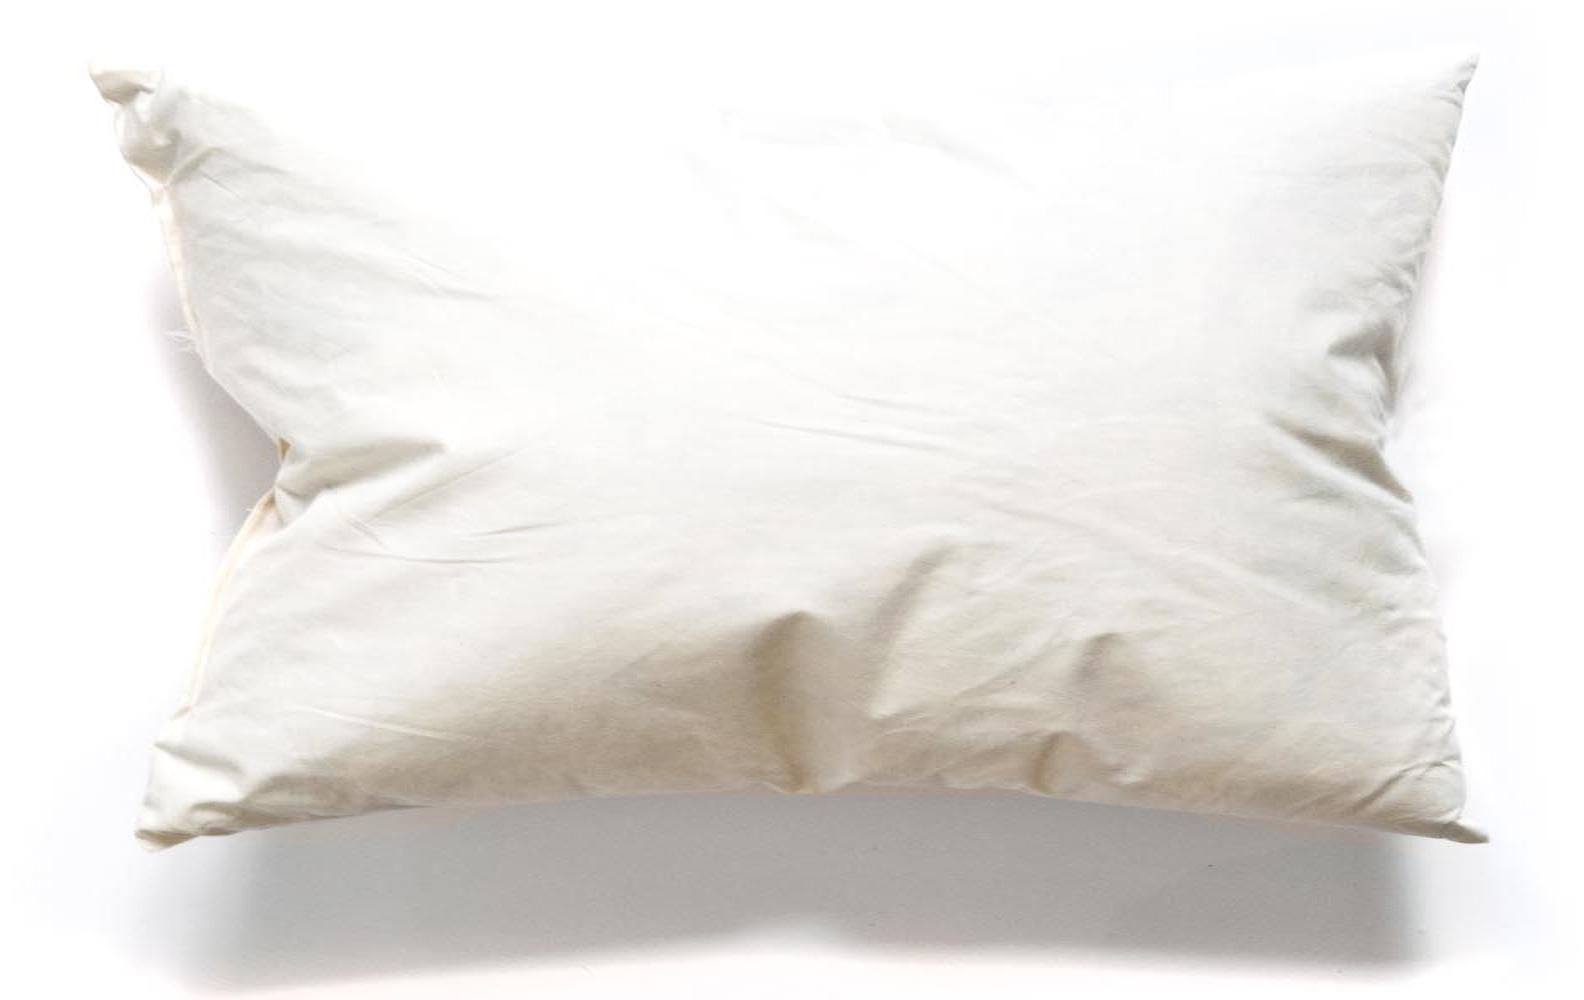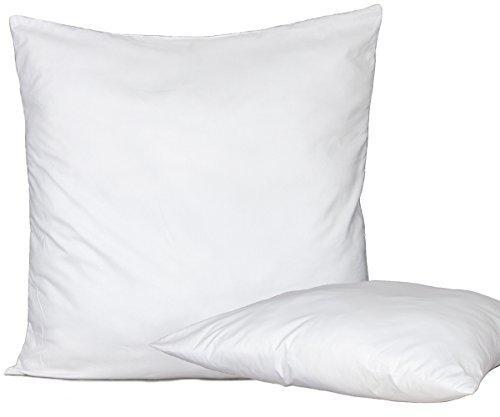The first image is the image on the left, the second image is the image on the right. Given the left and right images, does the statement "Two pillows are visible in the left image, while there is just one pillow on the right" hold true? Answer yes or no. No. The first image is the image on the left, the second image is the image on the right. Given the left and right images, does the statement "One image shows a single white rectangular pillow, and the other image shows a square upright pillow overlapping a pillow on its side." hold true? Answer yes or no. Yes. 